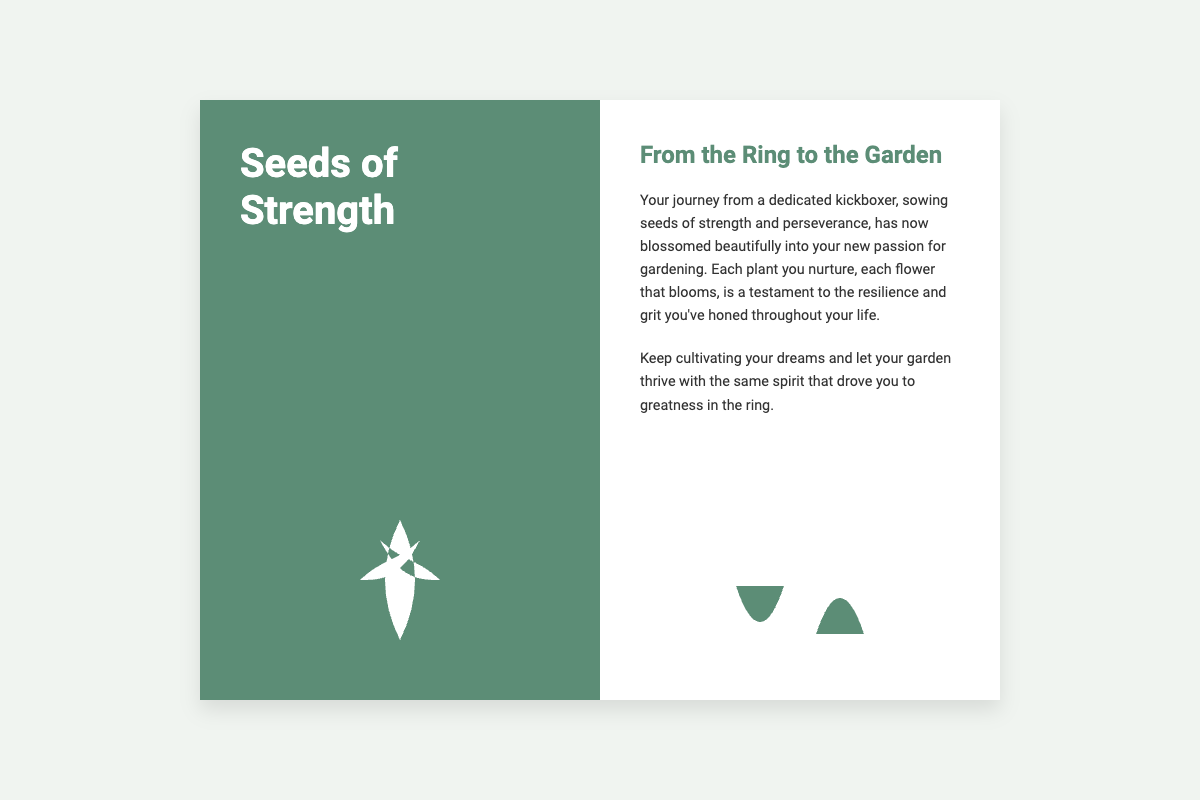What is the title of the card? The title of the card is prominently displayed on the cover, showcasing the theme of the card.
Answer: Seeds of Strength What is the main theme of the card? The card conveys a journey of transformation from kickboxing to gardening, emphasizing strength and perseverance.
Answer: Transformation What color is the background of the card? The card features a light background color that supports the overall serene and minimalist design.
Answer: Light gray What does the header inside the card say? The header inside the card provides context to the inspiring message and connects the kickboxing past to the gardening present.
Answer: From the Ring to the Garden What does gardening symbolize in the card? Gardening symbolizes the flourishing of qualities like resilience and dedication that were developed through kickboxing.
Answer: Resilience What is highlighted as the outcome of dedication in kickboxing? The text implies that the dedication put into kickboxing leads to a rich and thriving new passion in gardening.
Answer: New passion How many sections does the card have? The card consists of a cover section and an inside section, creatively separated to present its message effectively.
Answer: Two sections What imagery is used on the cover? The cover features a visual element that represents growth and nature, aligning with the theme of the card.
Answer: Sprouting seeds What message does the inside text encourage? The text encourages continuing to cultivate dreams and letting the garden thrive, paralleling the spirit from kickboxing.
Answer: Cultivating dreams What type of card is this? The card is specifically designed to offer inspiration and encouragement, utilizing themes from life experiences.
Answer: Greeting card 